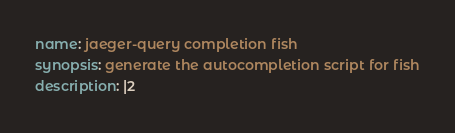Convert code to text. <code><loc_0><loc_0><loc_500><loc_500><_YAML_>name: jaeger-query completion fish
synopsis: generate the autocompletion script for fish
description: |2
</code> 